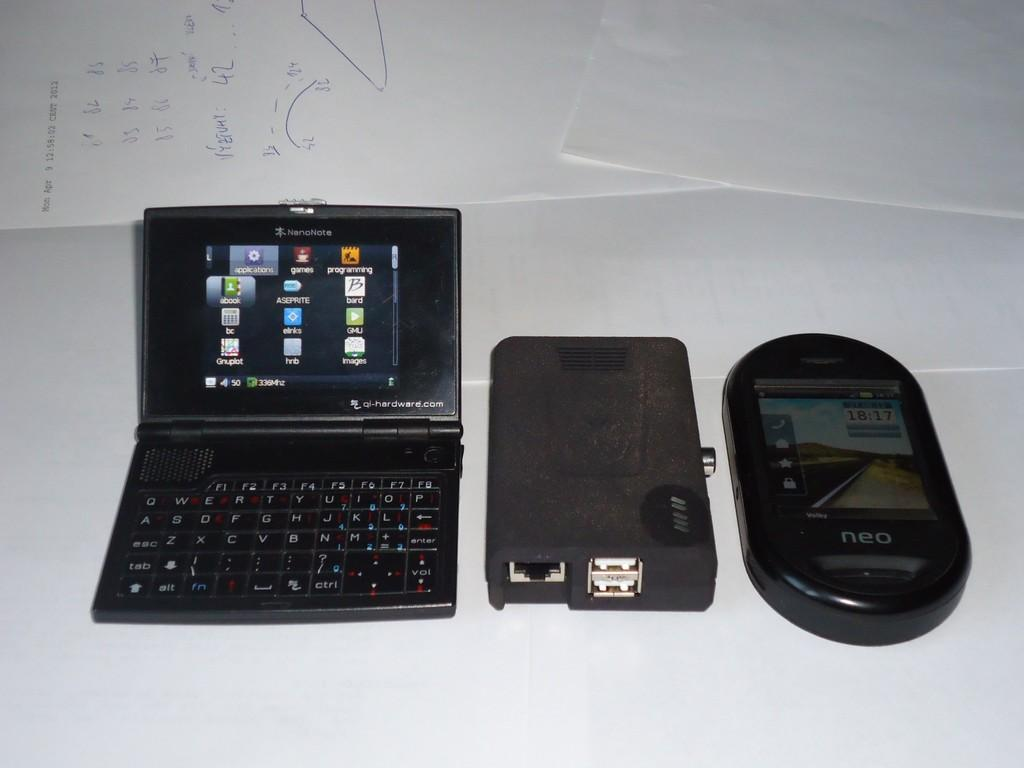<image>
Describe the image concisely. a nanonote computer is laying with two other devices on a table 